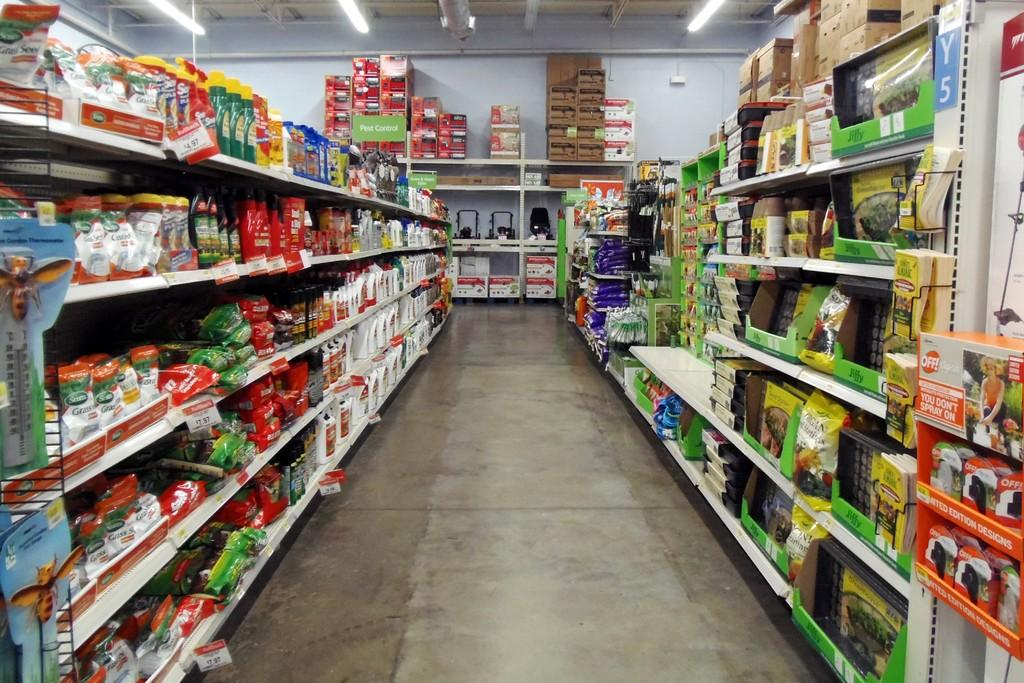<image>
Share a concise interpretation of the image provided. An aisle of produce, one of which says limited edition designs. 